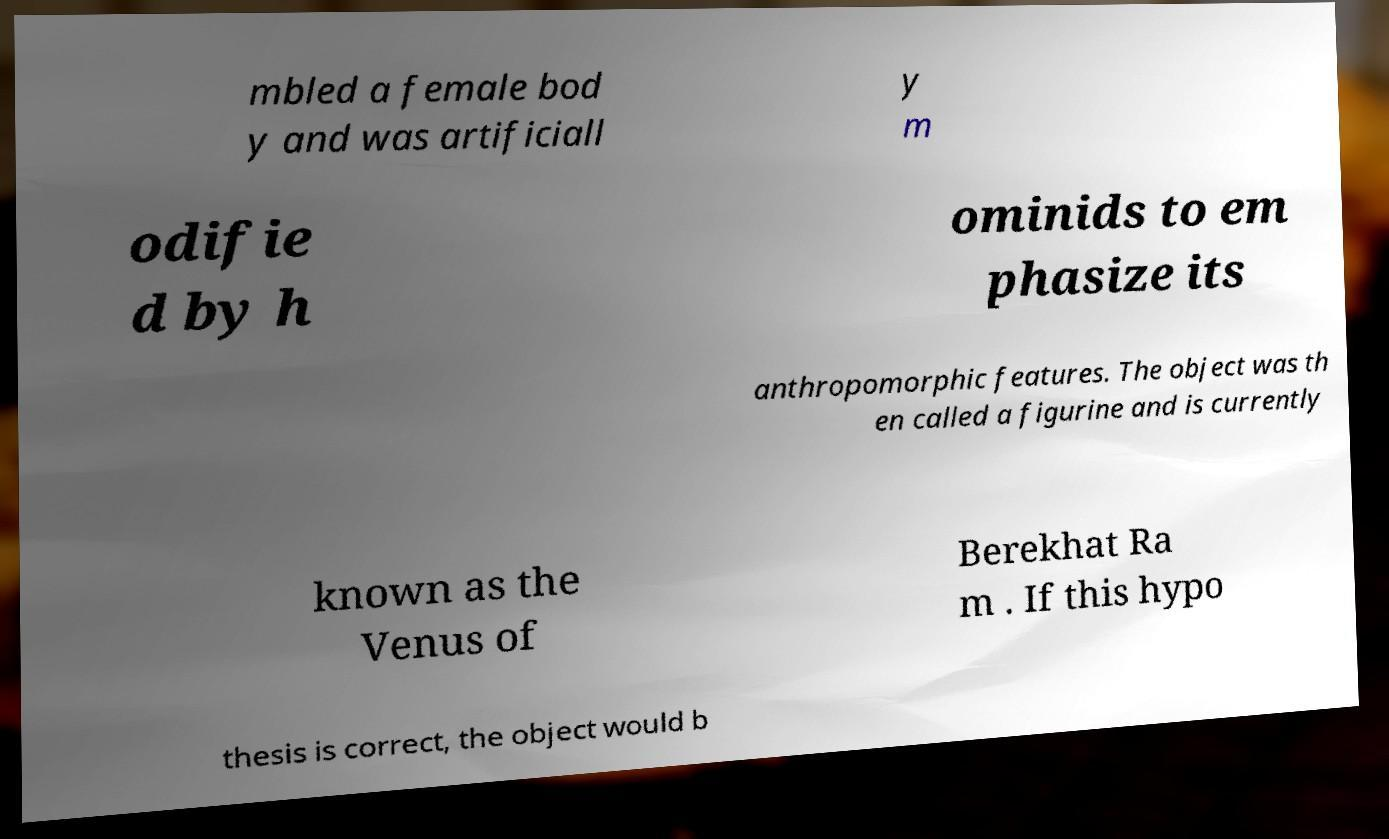Please read and relay the text visible in this image. What does it say? mbled a female bod y and was artificiall y m odifie d by h ominids to em phasize its anthropomorphic features. The object was th en called a figurine and is currently known as the Venus of Berekhat Ra m . If this hypo thesis is correct, the object would b 